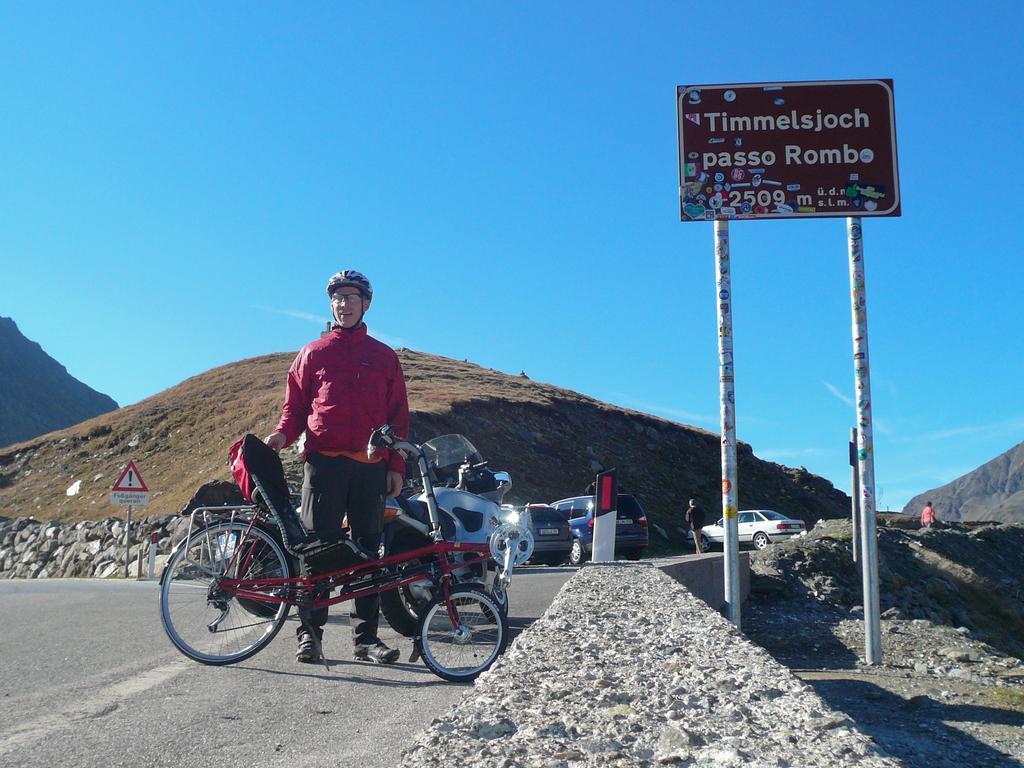What is the person in the image doing? The person is standing in the image and holding a bicycle. What can be seen in the background of the image? There are vehicles, people, hills, and boards visible in the background. Can you describe the setting of the image? The image shows a person holding a bicycle, with vehicles, people, hills, and boards in the background. What type of belief system is being practiced by the town in the image? There is no town present in the image, so it is not possible to determine what belief system might be practiced there. 